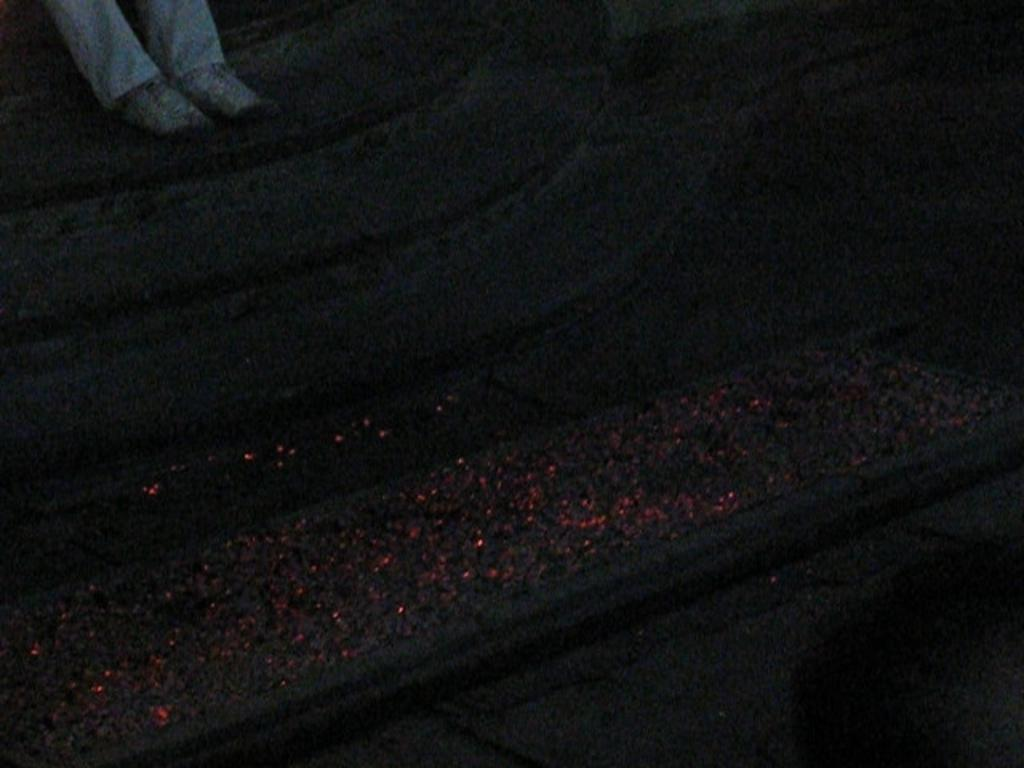What body parts are visible in the image? There are two human legs in the image. What are the legs resting on or in contact with? The legs are on something. How would you describe the lighting in the image? The image is dark. What is the queen doing in the image? There is no queen present in the image; it only features two human legs. How long does it take for the minute hand to move in the image? There is no clock or time-related object present in the image, so it's not possible to determine the movement of a minute hand. 